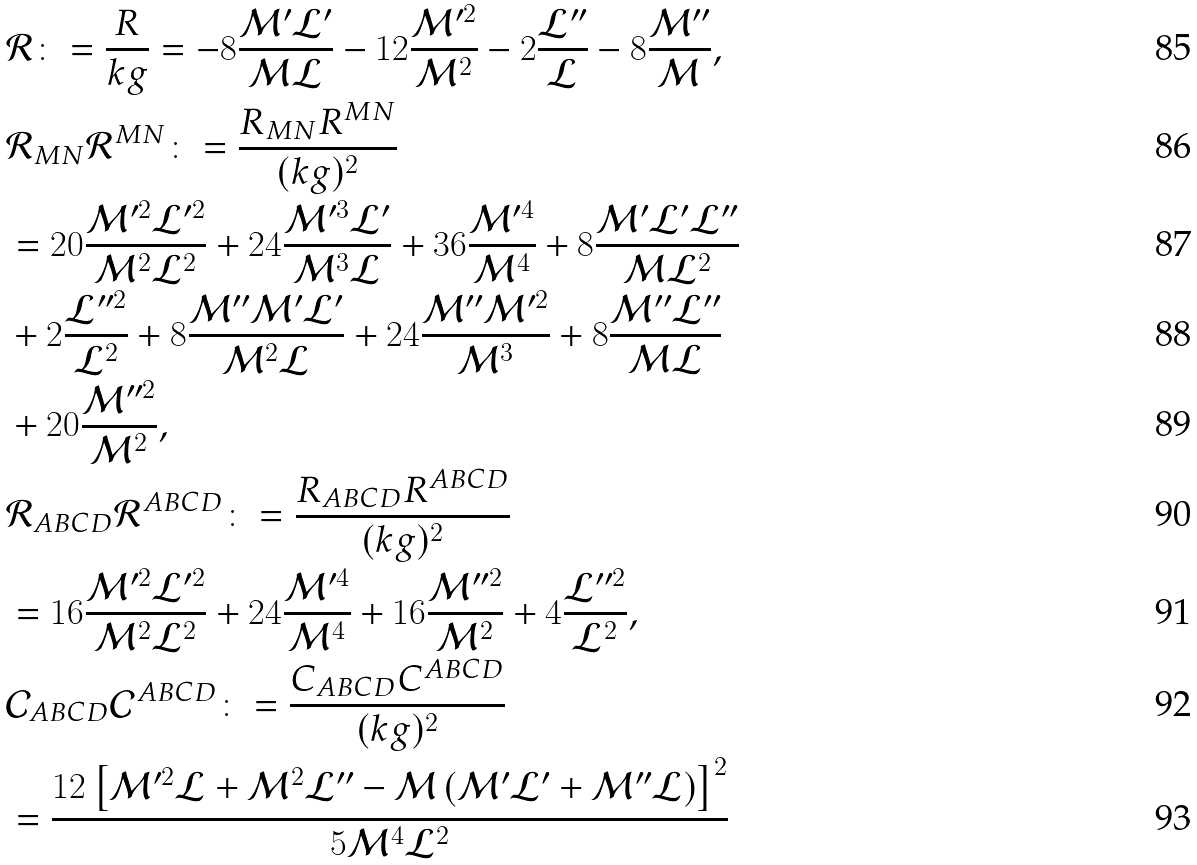Convert formula to latex. <formula><loc_0><loc_0><loc_500><loc_500>& \mathcal { R } \colon = \frac { R } { k g } = - 8 \frac { \mathcal { M } ^ { \prime } \mathcal { L } ^ { \prime } } { \mathcal { M } \mathcal { L } } - 1 2 \frac { \mathcal { M } ^ { \prime 2 } } { \mathcal { M } ^ { 2 } } - 2 \frac { \mathcal { L } ^ { \prime \prime } } { \mathcal { L } } - 8 \frac { \mathcal { M } ^ { \prime \prime } } { \mathcal { M } } , \\ & \mathcal { R } _ { M N } \mathcal { R } ^ { M N } \colon = \frac { R _ { M N } R ^ { M N } } { ( k g ) ^ { 2 } } \\ & = 2 0 \frac { \mathcal { M } ^ { \prime 2 } \mathcal { L } ^ { \prime 2 } } { \mathcal { M } ^ { 2 } \mathcal { L } ^ { 2 } } + 2 4 \frac { \mathcal { M } ^ { \prime 3 } \mathcal { L } ^ { \prime } } { \mathcal { M } ^ { 3 } \mathcal { L } } + 3 6 \frac { \mathcal { M } ^ { \prime 4 } } { \mathcal { M } ^ { 4 } } + 8 \frac { \mathcal { M } ^ { \prime } \mathcal { L } ^ { \prime } \mathcal { L } ^ { \prime \prime } } { \mathcal { M } \mathcal { L } ^ { 2 } } \\ & + 2 \frac { \mathcal { L } ^ { \prime \prime 2 } } { \mathcal { L } ^ { 2 } } + 8 \frac { \mathcal { M } ^ { \prime \prime } \mathcal { M } ^ { \prime } \mathcal { L } ^ { \prime } } { \mathcal { M } ^ { 2 } \mathcal { L } } + 2 4 \frac { \mathcal { M } ^ { \prime \prime } \mathcal { M } ^ { \prime 2 } } { \mathcal { M } ^ { 3 } } + 8 \frac { \mathcal { M } ^ { \prime \prime } \mathcal { L } ^ { \prime \prime } } { \mathcal { M } \mathcal { L } } \\ & + 2 0 \frac { \mathcal { M } ^ { \prime \prime 2 } } { \mathcal { M } ^ { 2 } } , \\ & \mathcal { R } _ { A B C D } \mathcal { R } ^ { A B C D } \colon = \frac { R _ { A B C D } R ^ { A B C D } } { ( k g ) ^ { 2 } } \\ & = 1 6 \frac { \mathcal { M } ^ { \prime 2 } \mathcal { L } ^ { \prime 2 } } { \mathcal { M } ^ { 2 } \mathcal { L } ^ { 2 } } + 2 4 \frac { \mathcal { M } ^ { \prime 4 } } { \mathcal { M } ^ { 4 } } + 1 6 \frac { \mathcal { M } ^ { \prime \prime 2 } } { \mathcal { M } ^ { 2 } } + 4 \frac { \mathcal { L } ^ { \prime \prime 2 } } { \mathcal { L } ^ { 2 } } , \\ & \mathcal { C } _ { A B C D } \mathcal { C } ^ { A B C D } \colon = \frac { C _ { A B C D } C ^ { A B C D } } { ( k g ) ^ { 2 } } \\ & = \frac { 1 2 \left [ \mathcal { M } ^ { \prime 2 } \mathcal { L } + \mathcal { M } ^ { 2 } \mathcal { L } ^ { \prime \prime } - \mathcal { M } \left ( \mathcal { M } ^ { \prime } \mathcal { L } ^ { \prime } + \mathcal { M } ^ { \prime \prime } \mathcal { L } \right ) \right ] ^ { 2 } } { 5 \mathcal { M } ^ { 4 } \mathcal { L } ^ { 2 } }</formula> 